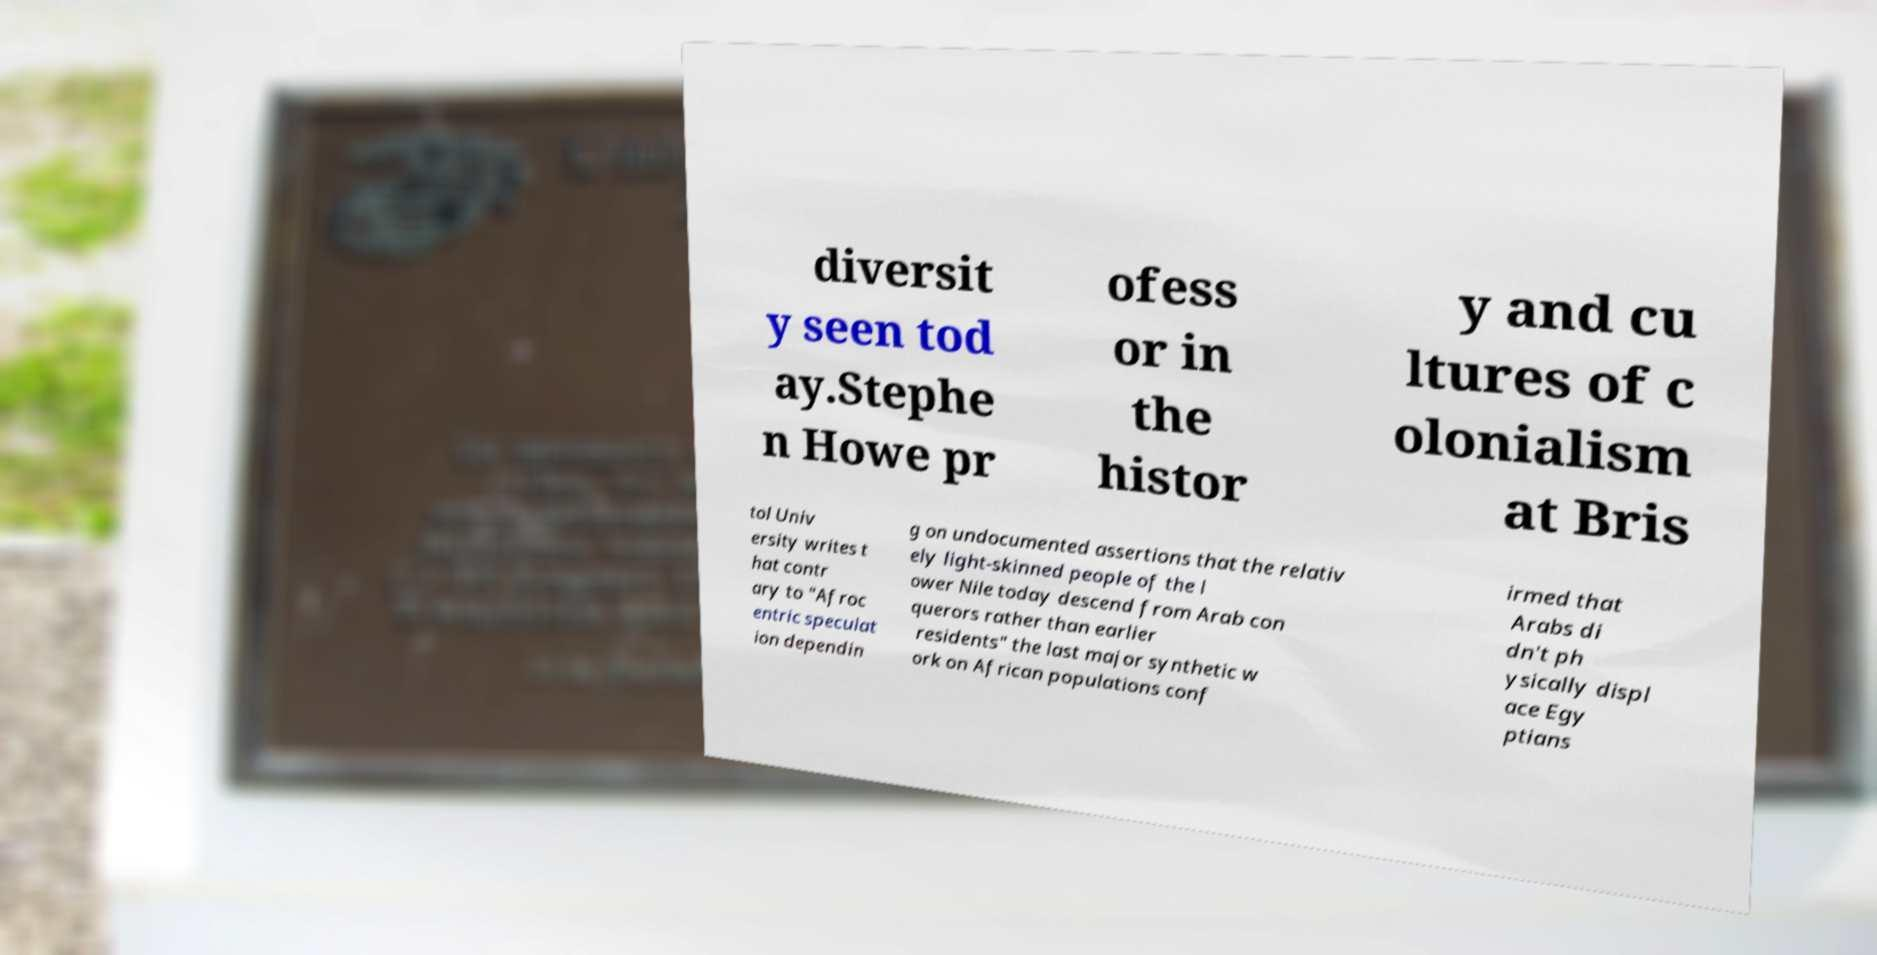Could you assist in decoding the text presented in this image and type it out clearly? diversit y seen tod ay.Stephe n Howe pr ofess or in the histor y and cu ltures of c olonialism at Bris tol Univ ersity writes t hat contr ary to "Afroc entric speculat ion dependin g on undocumented assertions that the relativ ely light-skinned people of the l ower Nile today descend from Arab con querors rather than earlier residents" the last major synthetic w ork on African populations conf irmed that Arabs di dn't ph ysically displ ace Egy ptians 